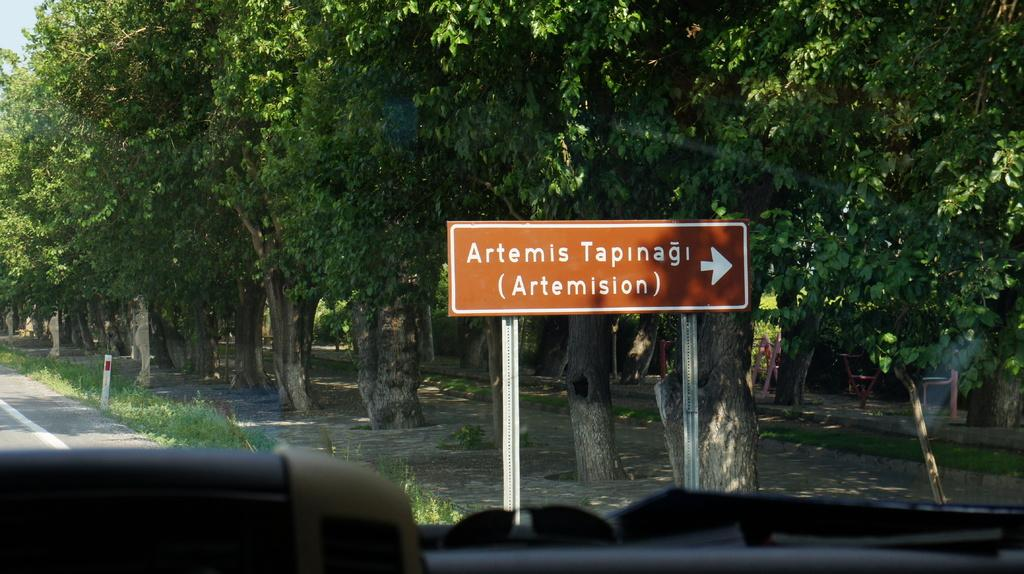What is attached to the poles in the image? There is a board attached to the poles in the image. What can be seen behind the board? Trees are visible behind the board. What else is present behind the board? There are some objects behind the board. What type of setting is depicted in the image? The image appears to show an inside view of a vehicle in front of the board. What type of fruit is hanging from the poles in the image? There is no fruit hanging from the poles in the image. 